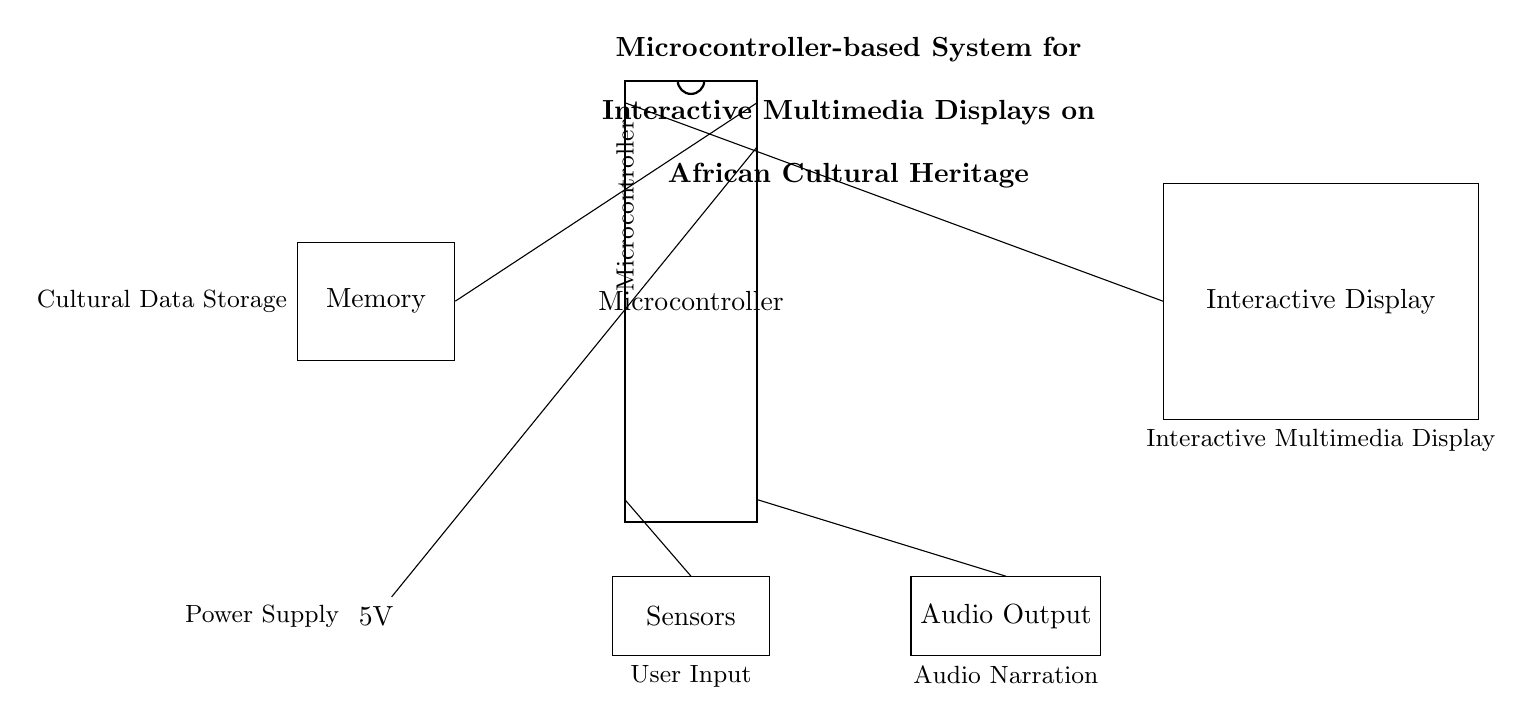What is the power supply voltage in this circuit? The power supply is labeled as 5V. This is indicated directly in the diagram at the power supply component.
Answer: 5V What type of microcontroller is used? The diagram shows a microcontroller labeled as "Microcontroller" without specific model details. Therefore, it indicates a generic representation.
Answer: Microcontroller How many output components are connected to the microcontroller? The microcontroller connects to three components: the interactive display, audio output, and sensors. Thus, the total number of outputs is three.
Answer: Three What is the purpose of the memory component in this circuit? The memory component is labeled as "Cultural Data Storage," indicating its function is to store cultural heritage data that can be accessed by the microcontroller.
Answer: Cultural Data Storage What is the connection between the power supply and the microcontroller? The connection is made through a short wire from the power supply to the microcontroller's pin labeled number 19, which is designated for power input.
Answer: To pin 19 How is user input processed in the circuit? User input is processed through the sensors component, which connects to the microcontroller's pin labeled number 10. This pin is responsible for handling the input from the sensors.
Answer: Through sensors 